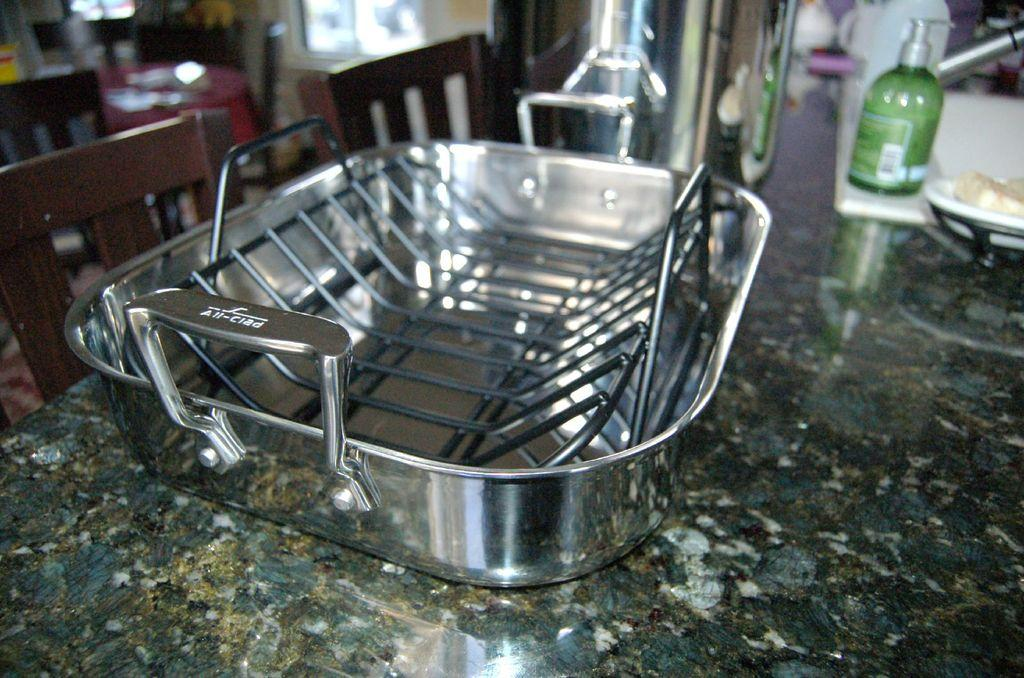What is placed on the table in the image? There is a vessel on the table in the image. What can be seen on the left side of the image? There are chairs on the left side of the image. Can you see a snail crawling on the vessel in the image? No, there is no snail present in the image. 